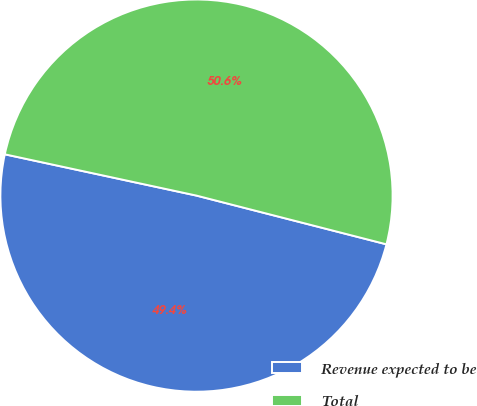Convert chart. <chart><loc_0><loc_0><loc_500><loc_500><pie_chart><fcel>Revenue expected to be<fcel>Total<nl><fcel>49.38%<fcel>50.62%<nl></chart> 